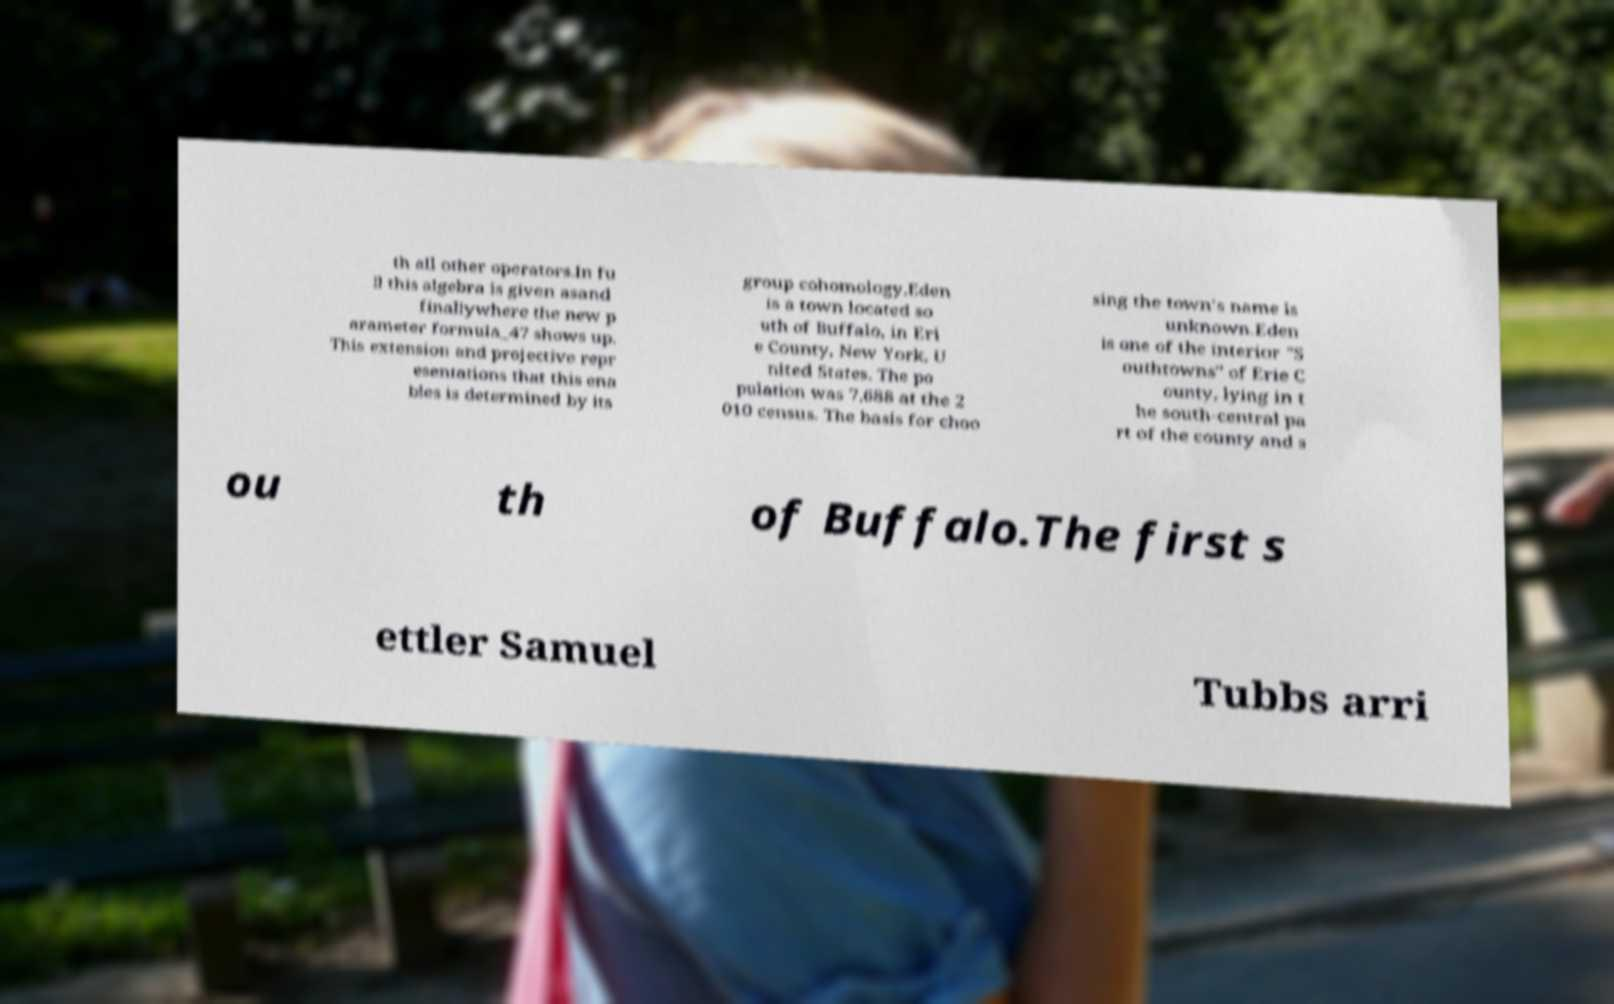I need the written content from this picture converted into text. Can you do that? th all other operators.In fu ll this algebra is given asand finallywhere the new p arameter formula_47 shows up. This extension and projective repr esentations that this ena bles is determined by its group cohomology.Eden is a town located so uth of Buffalo, in Eri e County, New York, U nited States. The po pulation was 7,688 at the 2 010 census. The basis for choo sing the town's name is unknown.Eden is one of the interior "S outhtowns" of Erie C ounty, lying in t he south-central pa rt of the county and s ou th of Buffalo.The first s ettler Samuel Tubbs arri 